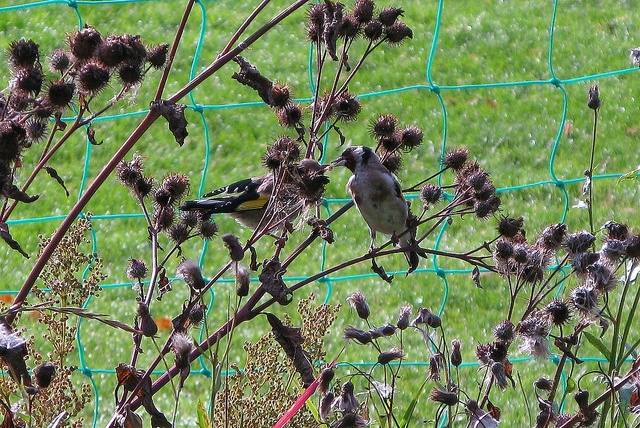Describe the objects in this image and their specific colors. I can see bird in green, black, and gray tones and bird in green, black, gray, olive, and darkgray tones in this image. 